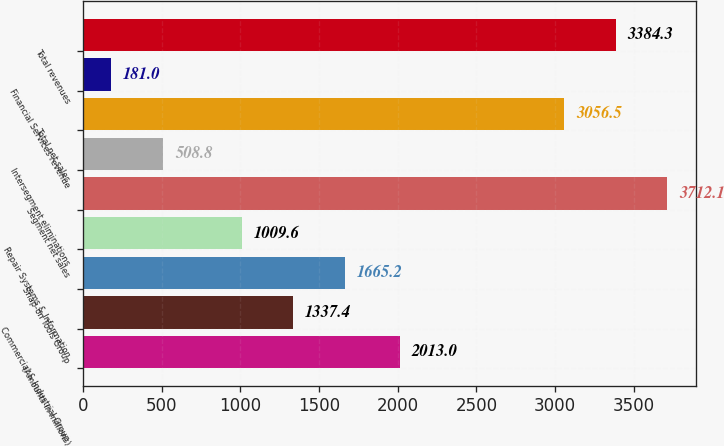Convert chart to OTSL. <chart><loc_0><loc_0><loc_500><loc_500><bar_chart><fcel>(Amounts in millions)<fcel>Commercial & Industrial Group<fcel>Snap-on Tools Group<fcel>Repair Systems & Information<fcel>Segment net sales<fcel>Intersegment eliminations<fcel>Total net sales<fcel>Financial Services revenue<fcel>Total revenues<nl><fcel>2013<fcel>1337.4<fcel>1665.2<fcel>1009.6<fcel>3712.1<fcel>508.8<fcel>3056.5<fcel>181<fcel>3384.3<nl></chart> 